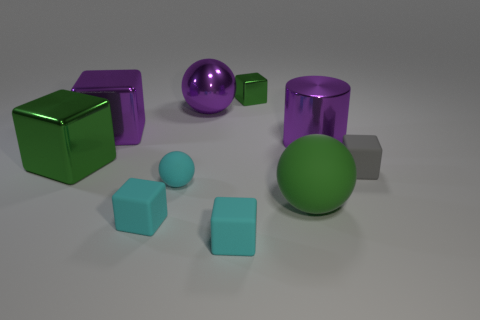There is a green thing that is the same size as the green matte ball; what shape is it?
Make the answer very short. Cube. There is a big ball that is to the right of the tiny metallic cube; what color is it?
Give a very brief answer. Green. What number of things are either objects that are to the left of the tiny shiny thing or small things that are on the right side of the large metal sphere?
Ensure brevity in your answer.  8. Do the gray object and the purple cube have the same size?
Offer a terse response. No. What number of cubes are either blue things or gray rubber things?
Your answer should be very brief. 1. How many matte objects are right of the large cylinder and left of the small gray thing?
Give a very brief answer. 0. There is a cyan sphere; is it the same size as the purple object on the right side of the green rubber thing?
Keep it short and to the point. No. Are there any large green rubber balls that are behind the large metallic object behind the purple metallic object that is on the left side of the purple metal sphere?
Ensure brevity in your answer.  No. What material is the big sphere right of the tiny green metal cube that is on the left side of the cylinder?
Make the answer very short. Rubber. There is a sphere that is to the left of the tiny green shiny block and in front of the gray object; what is it made of?
Give a very brief answer. Rubber. 